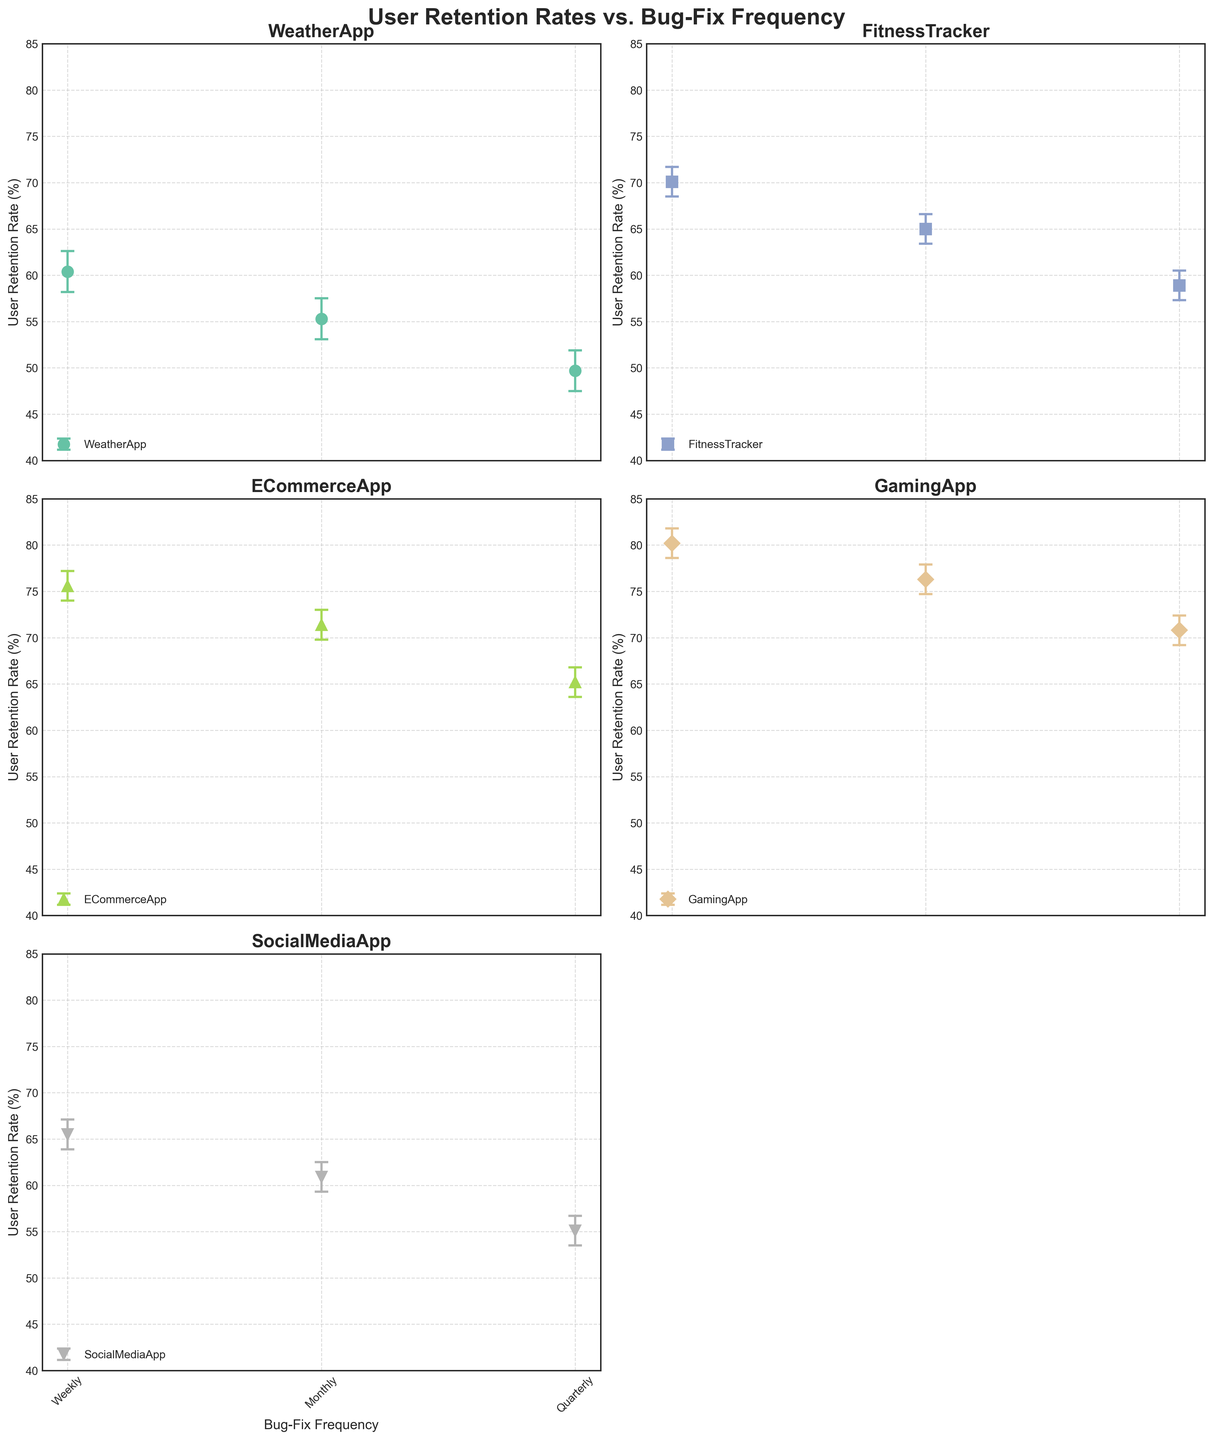What is the highest user retention rate among all apps and all frequencies? The highest user retention rate occurs at 80.2% for the GamingApp when the bug-fix frequency is weekly. This value can be found in the subplot for the GamingApp.
Answer: 80.2% How many bug-fix frequencies are analyzed per app? The x-axis labels in each subplot show the bug-fix frequencies "Weekly," "Monthly," and "Quarterly." This can be counted as three bug-fix frequencies per app.
Answer: 3 Which app shows the greatest decrease in user retention rate from weekly to quarterly bug-fix frequency? The GamingApp shows the greatest decrease in user retention rate from weekly to quarterly bug-fix frequency, dropping from 80.2% to 70.8%, a decrease of 9.4 percentage points. This is calculated by subtracting 70.8% from 80.2%.
Answer: GamingApp What is the title of the figure? The title is displayed at the top of the figure as ‘User Retention Rates vs. Bug-Fix Frequency'.
Answer: User Retention Rates vs. Bug-Fix Frequency Which app has the smallest range for user retention rates across all frequencies? The ECommerceApp ranges from 65.2% to 75.6%, a span of 10.4 percentage points, compared to other apps which have larger ranges. This is determined by identifying the maximum and minimum values in the ECommerceApp's subplot and computing their difference.
Answer: ECommerceApp What is the user retention rate for FitnessTracker with a monthly bug-fix frequency? In the subplot for FitnessTracker, the user retention rate for a monthly bug-fix frequency is shown at 65.0%.
Answer: 65.0% Among SocialMediaApp and WeatherApp, which app has a higher retention rate when the bug-fix frequency is monthly? At monthly bug-fix frequency, SocialMediaApp has a user retention rate of 60.9%, while WeatherApp has a retention rate of 55.3%. Thus, SocialMediaApp has a higher retention rate.
Answer: SocialMediaApp What user retention rates are within the 95% confidence interval for ECommerceApp with weekly bug-fix frequency? The 95% confidence interval for ECommerceApp with weekly bug-fix frequency ranges from 74.0% to 77.2%, as shown by the error bars. Any user retention rate within this range is within the confidence interval.
Answer: 74.0% to 77.2% Which app has the lowest retention rate for quarterly bug-fix frequency? By looking at the subplots, WeatherApp has the lowest retention rate for quarterly bug-fix frequency at 49.7%.
Answer: WeatherApp How does the user retention rate change for WeatherApp from weekly to monthly bug-fix frequency? For WeatherApp, the user retention rate decreases from 60.4% (weekly) to 55.3% (monthly). This is determined by checking the y-values at the corresponding frequency points within the WeatherApp subplot.
Answer: Decreases by 5.1% 